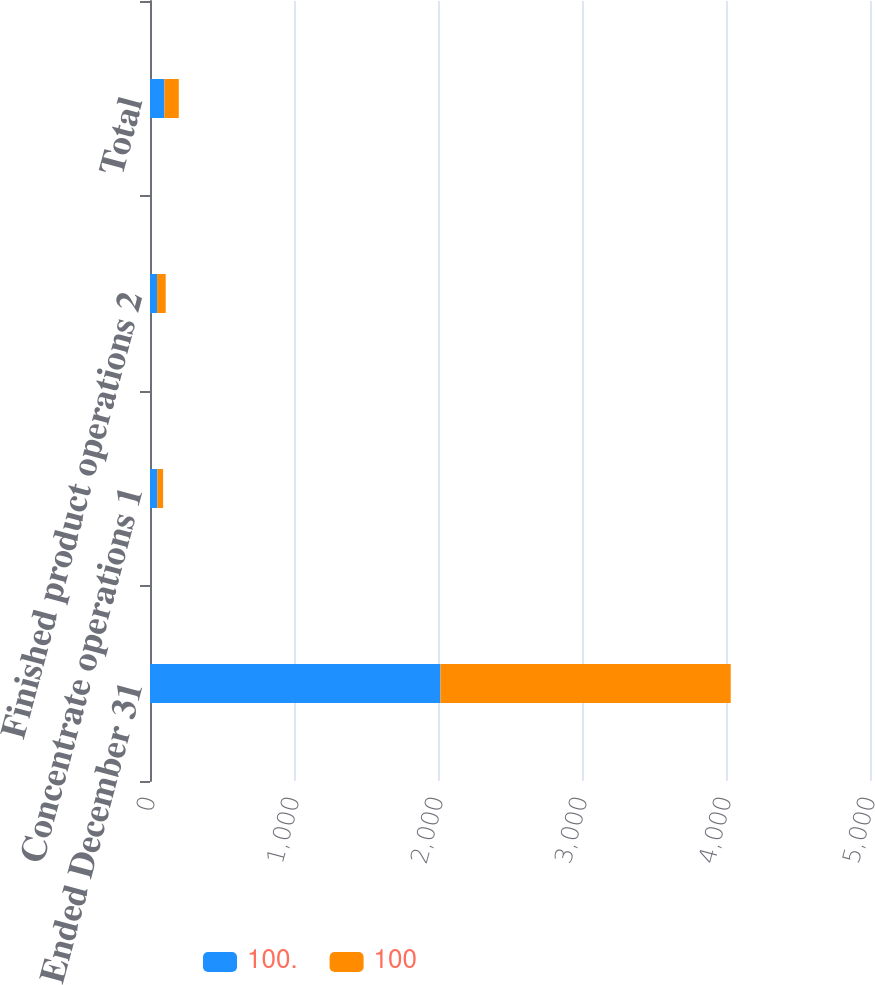<chart> <loc_0><loc_0><loc_500><loc_500><stacked_bar_chart><ecel><fcel>Year Ended December 31<fcel>Concentrate operations 1<fcel>Finished product operations 2<fcel>Total<nl><fcel>100<fcel>2017<fcel>51<fcel>49<fcel>100<nl><fcel>100<fcel>2016<fcel>40<fcel>60<fcel>100<nl></chart> 